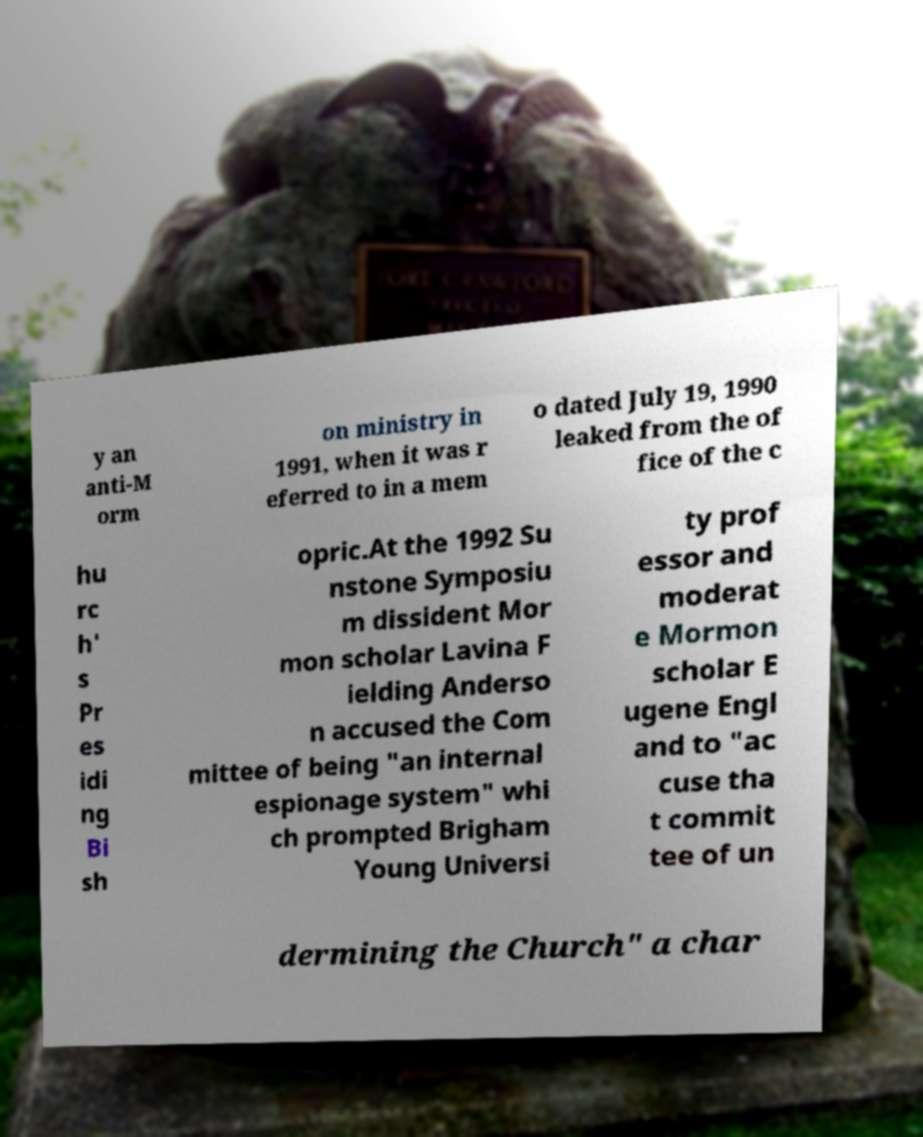Please read and relay the text visible in this image. What does it say? y an anti-M orm on ministry in 1991, when it was r eferred to in a mem o dated July 19, 1990 leaked from the of fice of the c hu rc h' s Pr es idi ng Bi sh opric.At the 1992 Su nstone Symposiu m dissident Mor mon scholar Lavina F ielding Anderso n accused the Com mittee of being "an internal espionage system" whi ch prompted Brigham Young Universi ty prof essor and moderat e Mormon scholar E ugene Engl and to "ac cuse tha t commit tee of un dermining the Church" a char 